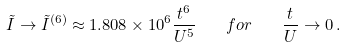Convert formula to latex. <formula><loc_0><loc_0><loc_500><loc_500>\tilde { I } \rightarrow \tilde { I } ^ { ( 6 ) } \approx 1 . 8 0 8 \times 1 0 ^ { 6 } \frac { t ^ { 6 } } { U ^ { 5 } } \quad f o r \quad \frac { t } { U } \rightarrow 0 \, .</formula> 